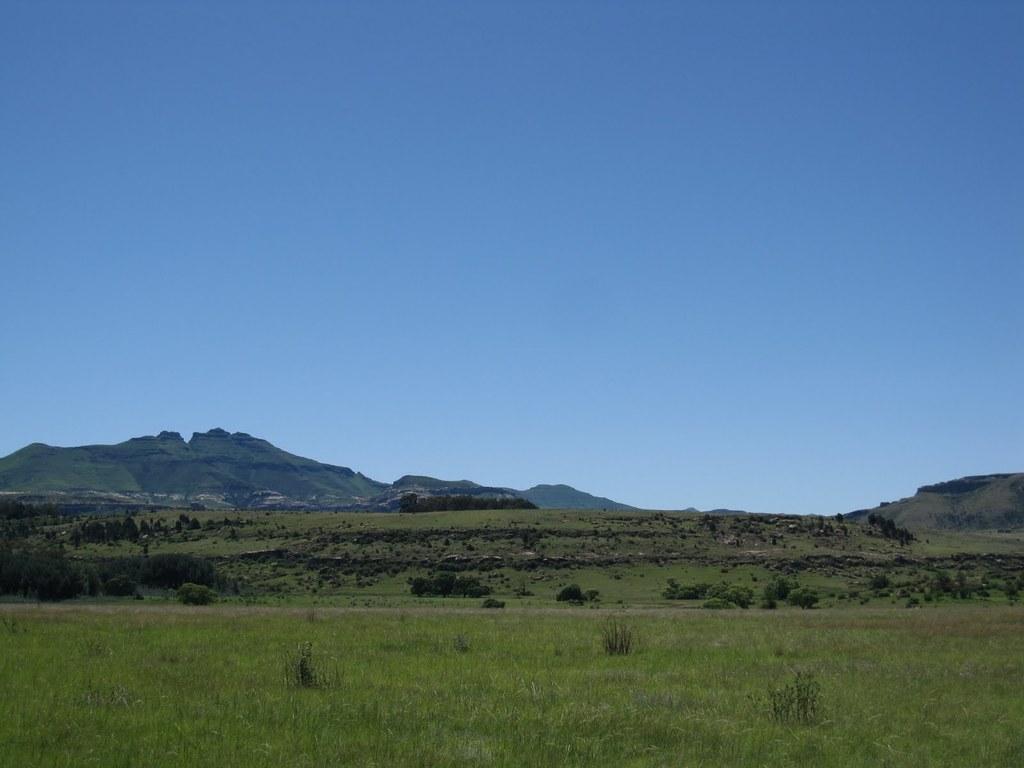Describe this image in one or two sentences. At the bottom of the image there is grass. In the background of the image there are mountains,trees. At the top of the image there is sky. 